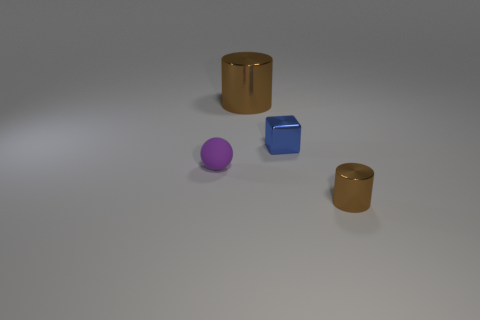How many blue things are either matte things or small blocks?
Offer a terse response. 1. What number of other things are there of the same material as the big brown thing
Make the answer very short. 2. There is a object to the right of the blue block; is its shape the same as the large brown metal object?
Give a very brief answer. Yes. Are any big brown balls visible?
Offer a terse response. No. Are there any other things that are the same shape as the blue object?
Offer a terse response. No. Are there more tiny metallic things that are on the right side of the small blue metal block than brown cubes?
Your response must be concise. Yes. There is a big metallic thing; are there any small shiny objects left of it?
Give a very brief answer. No. Do the purple rubber object and the block have the same size?
Your answer should be compact. Yes. There is another brown thing that is the same shape as the tiny brown shiny object; what is its size?
Provide a succinct answer. Large. Are there any other things that have the same size as the purple sphere?
Offer a terse response. Yes. 